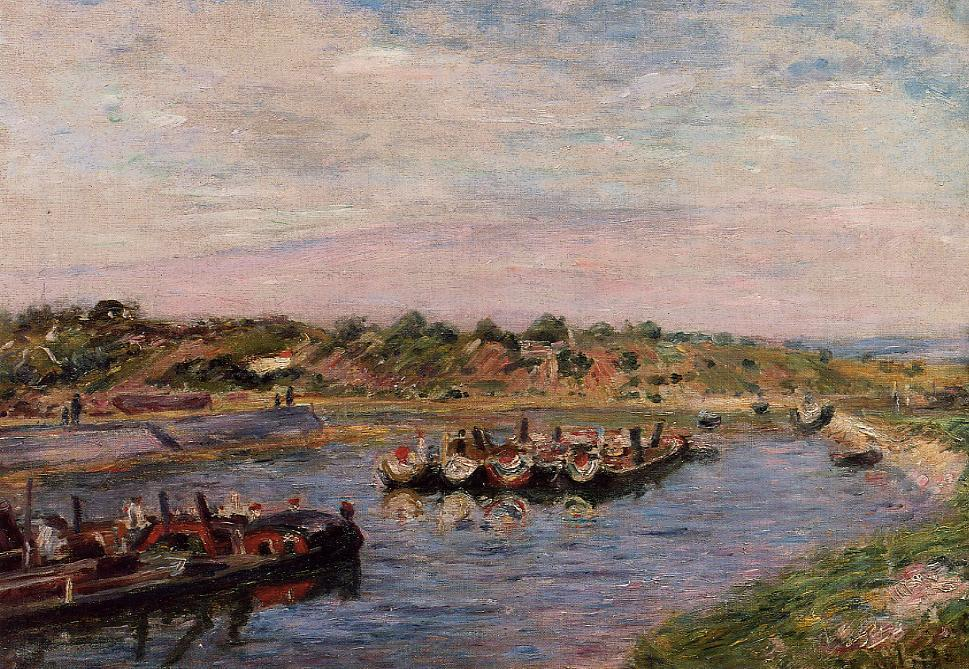What time of day and year might this painting depict, based on its color and light? The soft, diffused light and the shadowing suggest that this scene could be depicting late afternoon. The gentle hues of pink and blue in the sky, mixed with the lush greens of the riverbank and the attire of the figures, might hint at spring or early summer, a time when colors are vibrant and the sun sets later in the day. 